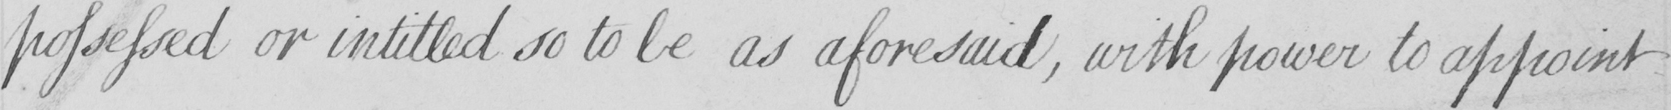Transcribe the text shown in this historical manuscript line. possessed or intitled so to be as aforesaid , with power to appoint 